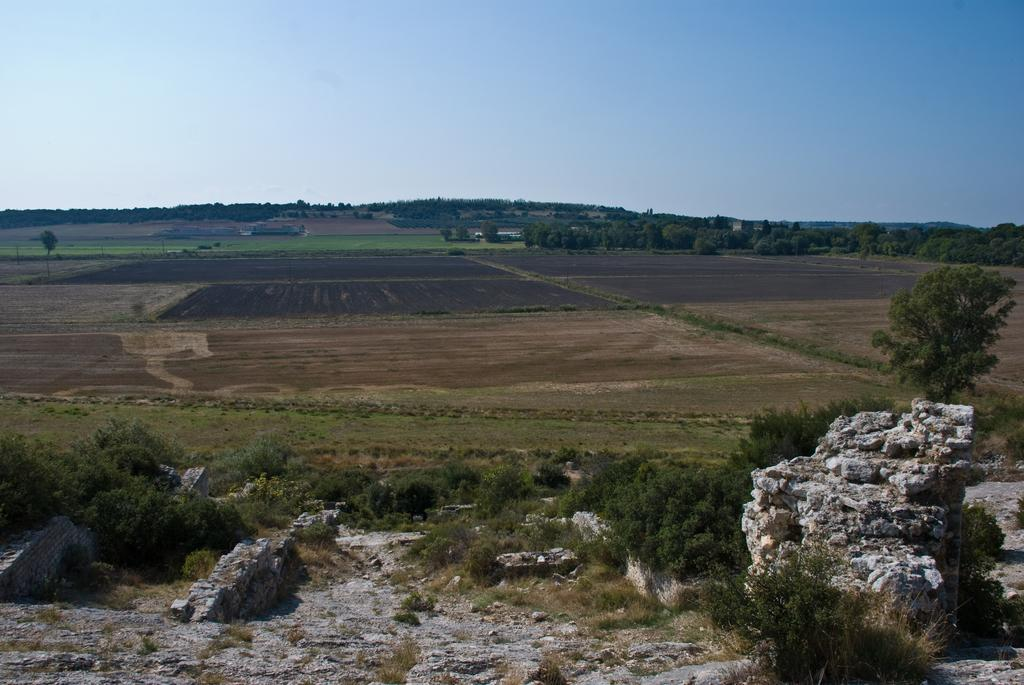What type of vegetation can be seen in the image? There is grass, plants, and trees in the image. What other natural elements are present in the image? There are rocks in the image. What can be seen in the background of the image? The sky is visible in the background of the image. What is the rate of eruption for the volcano in the image? There is no volcano present in the image, so it is not possible to determine the rate of eruption. 